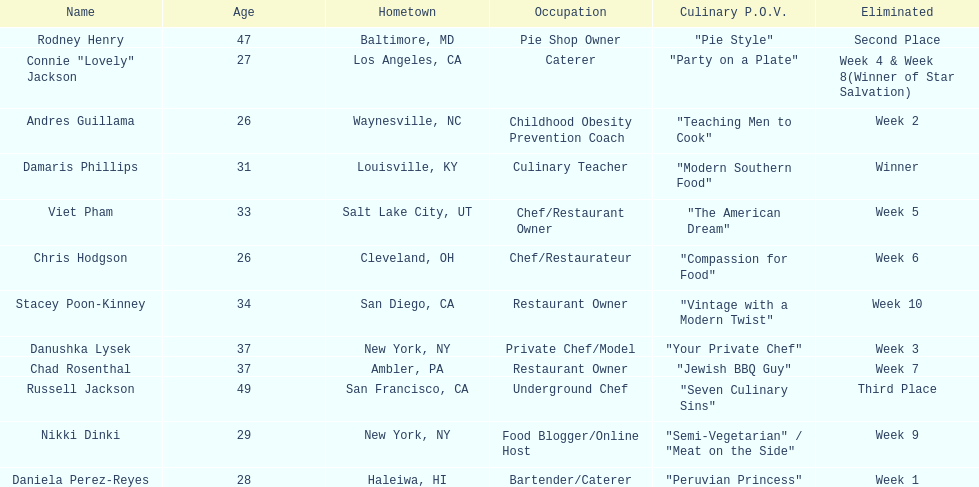Who was eliminated first, nikki dinki or viet pham? Viet Pham. 